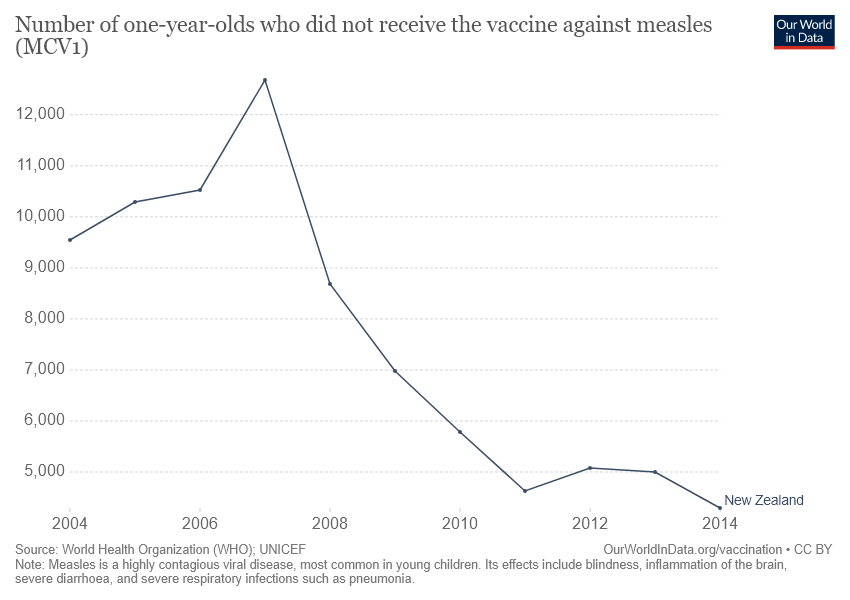Indicate a few pertinent items in this graphic. In 2007, the highest number of one-year-olds who did not receive the measles vaccine was recorded. According to the graph, the data for one-year-olds who did not receive the vaccine against measles in New Zealand is represented. 